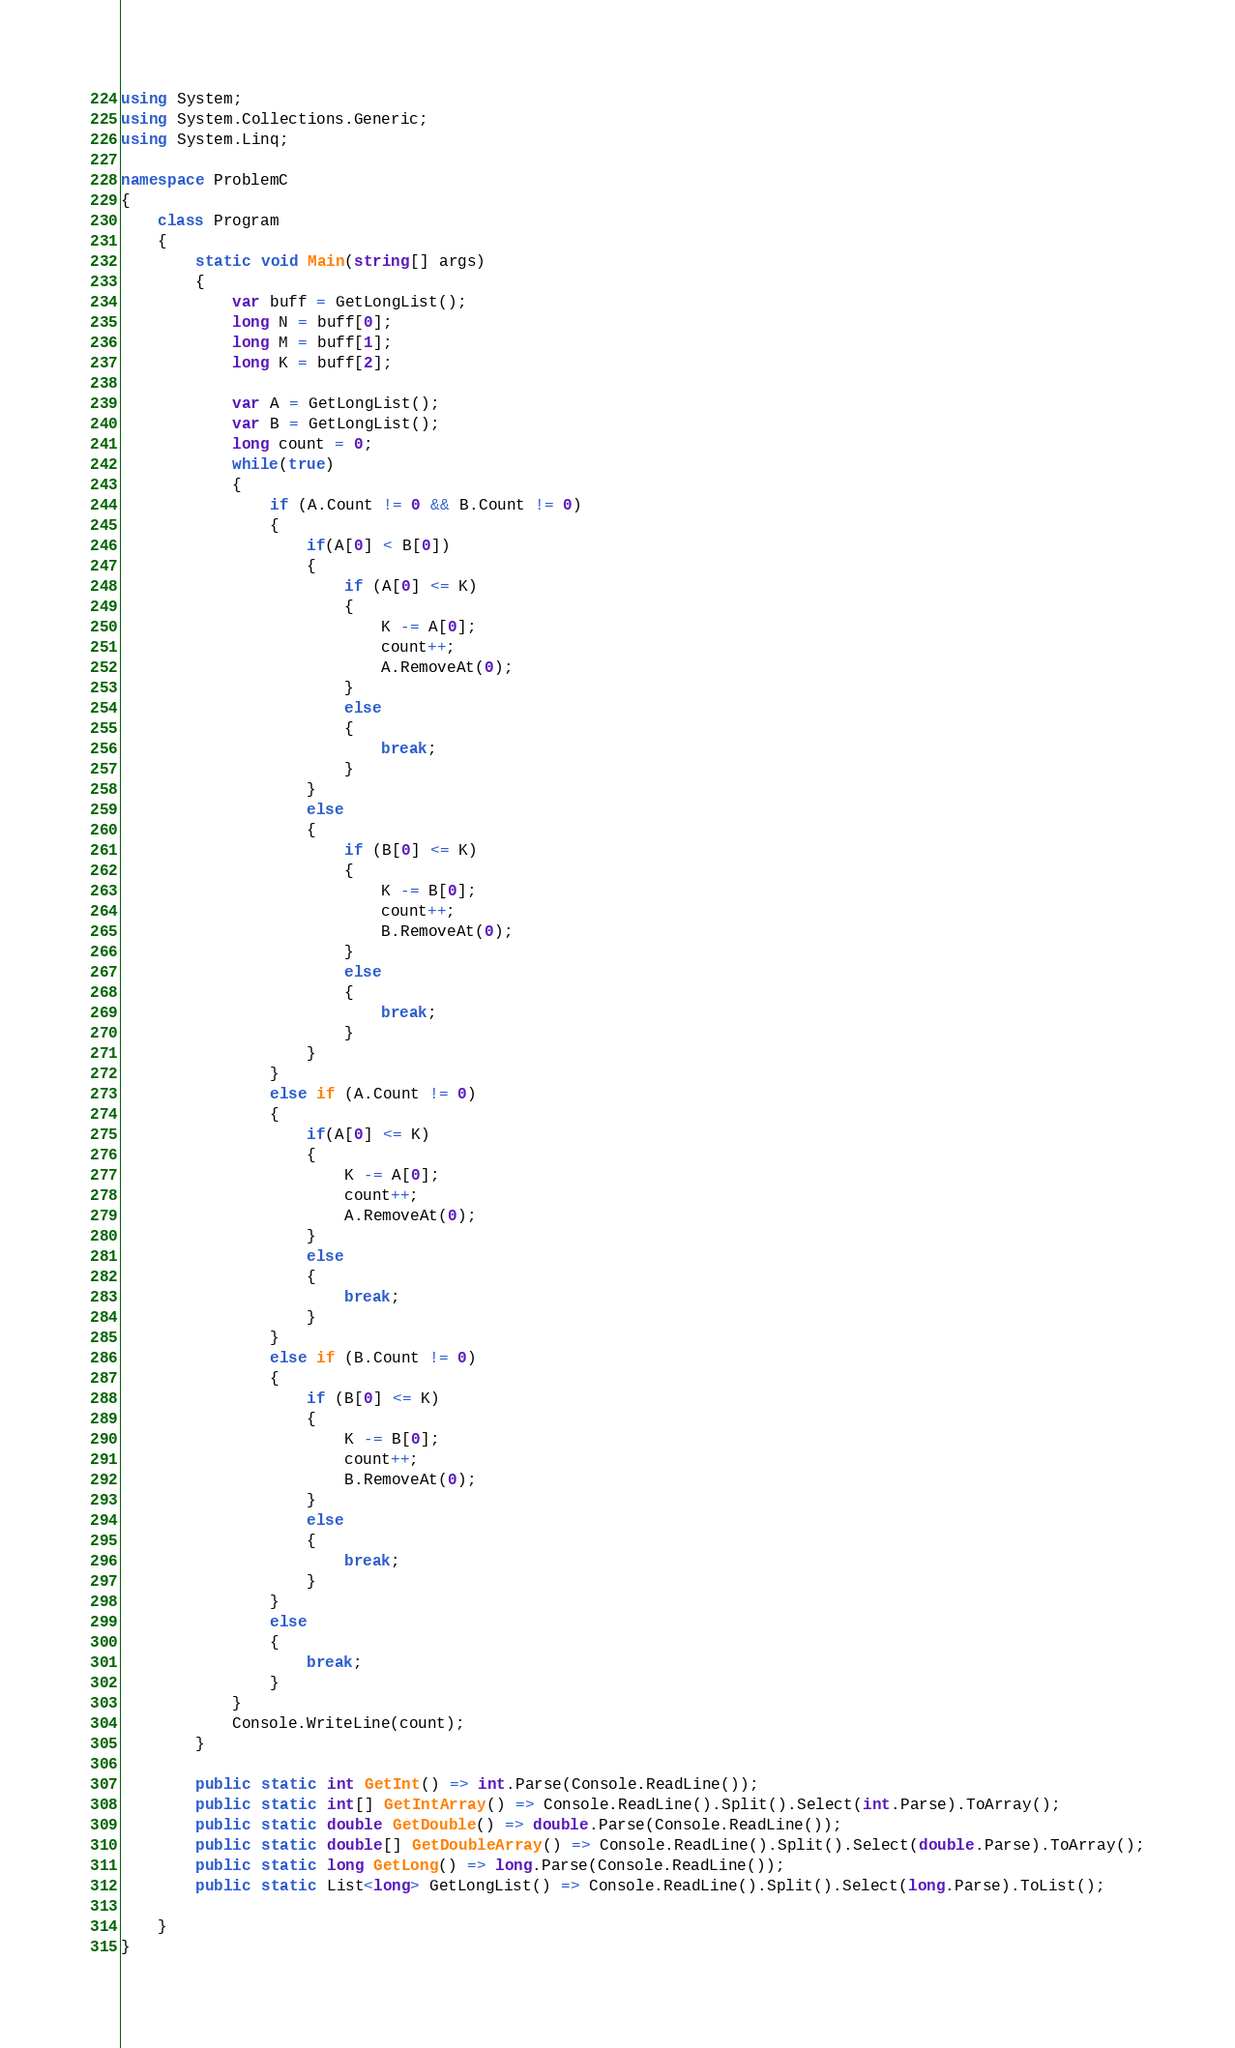Convert code to text. <code><loc_0><loc_0><loc_500><loc_500><_C#_>using System;
using System.Collections.Generic;
using System.Linq;

namespace ProblemC
{
    class Program
    {
        static void Main(string[] args)
        {
            var buff = GetLongList();
            long N = buff[0];
            long M = buff[1];
            long K = buff[2];

            var A = GetLongList();
            var B = GetLongList();
            long count = 0;
            while(true)
            {
                if (A.Count != 0 && B.Count != 0)
                {
                    if(A[0] < B[0])
                    {
                        if (A[0] <= K)
                        {
                            K -= A[0];
                            count++;
                            A.RemoveAt(0);
                        }
                        else
                        {
                            break;
                        }
                    }
                    else
                    {
                        if (B[0] <= K)
                        {
                            K -= B[0];
                            count++;
                            B.RemoveAt(0);
                        }
                        else
                        {
                            break;
                        }
                    }
                }
                else if (A.Count != 0)
                {
                    if(A[0] <= K)
                    {
                        K -= A[0];
                        count++;
                        A.RemoveAt(0);
                    }
                    else
                    {
                        break;
                    }
                }
                else if (B.Count != 0)
                {
                    if (B[0] <= K)
                    {
                        K -= B[0];
                        count++;
                        B.RemoveAt(0);
                    }
                    else
                    {
                        break;
                    }
                }
                else
                {
                    break;
                }
            }
            Console.WriteLine(count);
        }

        public static int GetInt() => int.Parse(Console.ReadLine());
        public static int[] GetIntArray() => Console.ReadLine().Split().Select(int.Parse).ToArray();
        public static double GetDouble() => double.Parse(Console.ReadLine());
        public static double[] GetDoubleArray() => Console.ReadLine().Split().Select(double.Parse).ToArray();
        public static long GetLong() => long.Parse(Console.ReadLine());
        public static List<long> GetLongList() => Console.ReadLine().Split().Select(long.Parse).ToList();

    }
}
</code> 